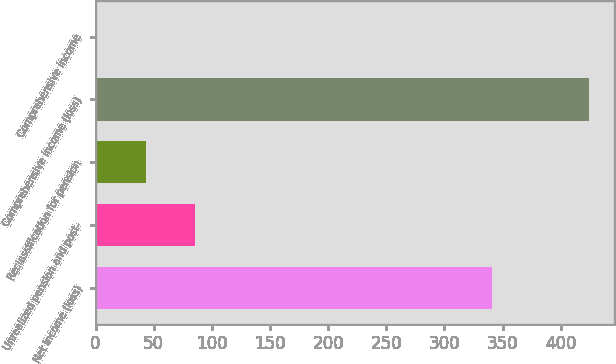Convert chart to OTSL. <chart><loc_0><loc_0><loc_500><loc_500><bar_chart><fcel>Net income (loss)<fcel>Unrealized pension and post-<fcel>Reclassification for pension<fcel>Comprehensive income (loss)<fcel>Comprehensive income<nl><fcel>341.2<fcel>85.62<fcel>43.16<fcel>424.6<fcel>0.7<nl></chart> 